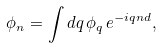Convert formula to latex. <formula><loc_0><loc_0><loc_500><loc_500>\phi _ { n } = \int { d q \, \phi _ { q } \, e ^ { - i q n d } } ,</formula> 